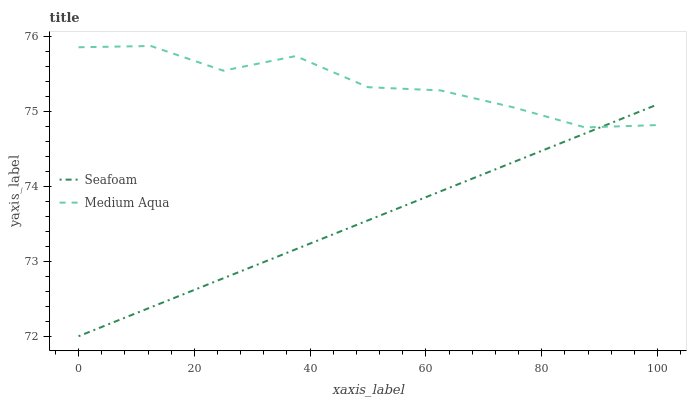Does Seafoam have the minimum area under the curve?
Answer yes or no. Yes. Does Medium Aqua have the maximum area under the curve?
Answer yes or no. Yes. Does Seafoam have the maximum area under the curve?
Answer yes or no. No. Is Seafoam the smoothest?
Answer yes or no. Yes. Is Medium Aqua the roughest?
Answer yes or no. Yes. Is Seafoam the roughest?
Answer yes or no. No. Does Seafoam have the lowest value?
Answer yes or no. Yes. Does Medium Aqua have the highest value?
Answer yes or no. Yes. Does Seafoam have the highest value?
Answer yes or no. No. Does Medium Aqua intersect Seafoam?
Answer yes or no. Yes. Is Medium Aqua less than Seafoam?
Answer yes or no. No. Is Medium Aqua greater than Seafoam?
Answer yes or no. No. 